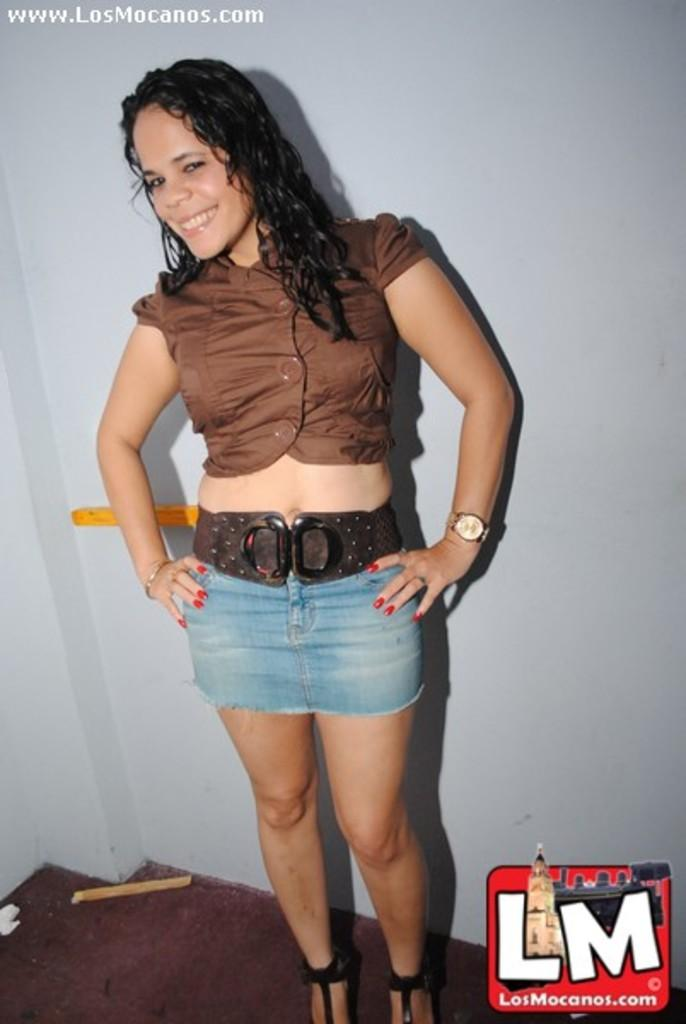Who is the main subject in the image? There is a woman in the image. What is the woman wearing? The woman is wearing a black and brown colored dress. How is the woman described? The woman is described as stunning. What can be seen in the background of the image? There is a white colored wall in the background of the image. What is the woman's desire for the system in the image? There is no mention of a system or the woman's desires in the image, so this question cannot be answered definitively. 